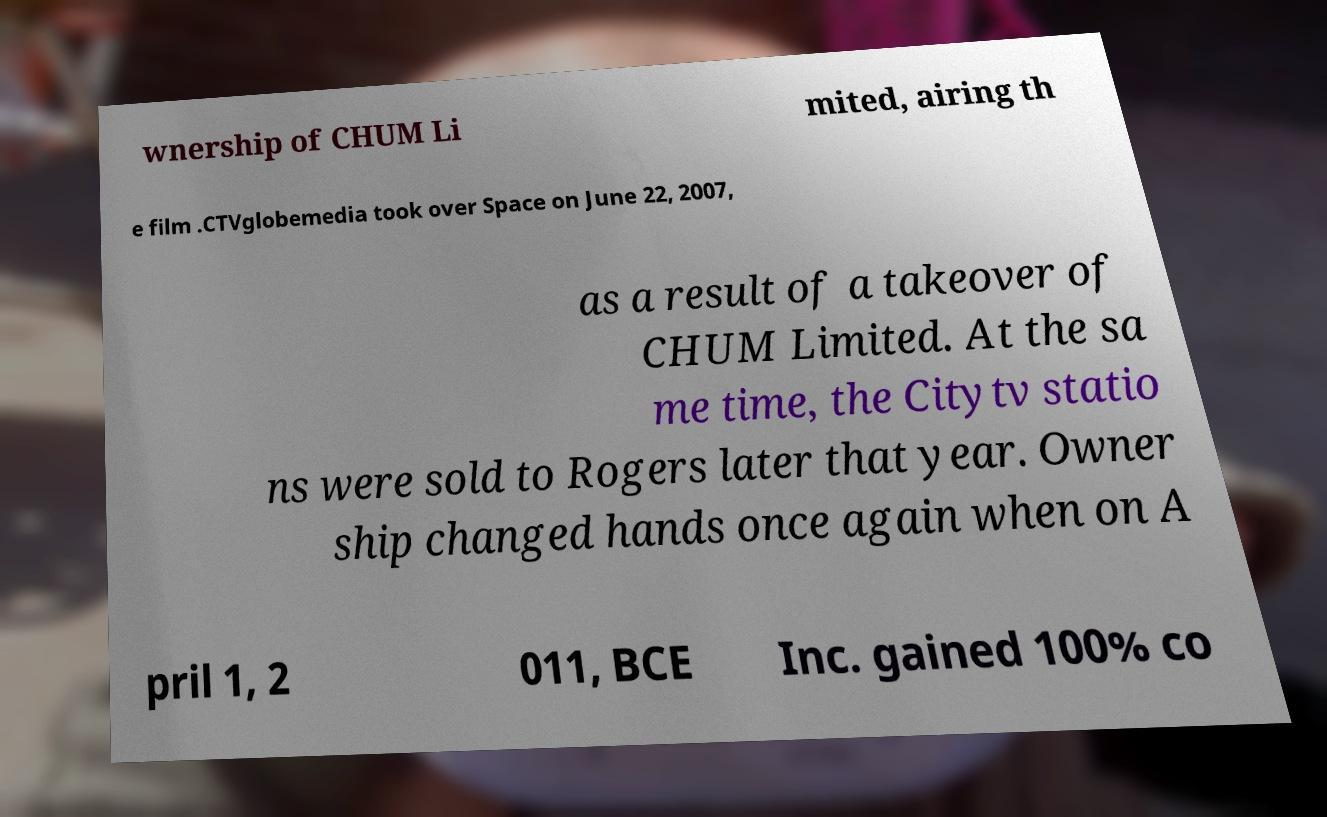For documentation purposes, I need the text within this image transcribed. Could you provide that? wnership of CHUM Li mited, airing th e film .CTVglobemedia took over Space on June 22, 2007, as a result of a takeover of CHUM Limited. At the sa me time, the Citytv statio ns were sold to Rogers later that year. Owner ship changed hands once again when on A pril 1, 2 011, BCE Inc. gained 100% co 